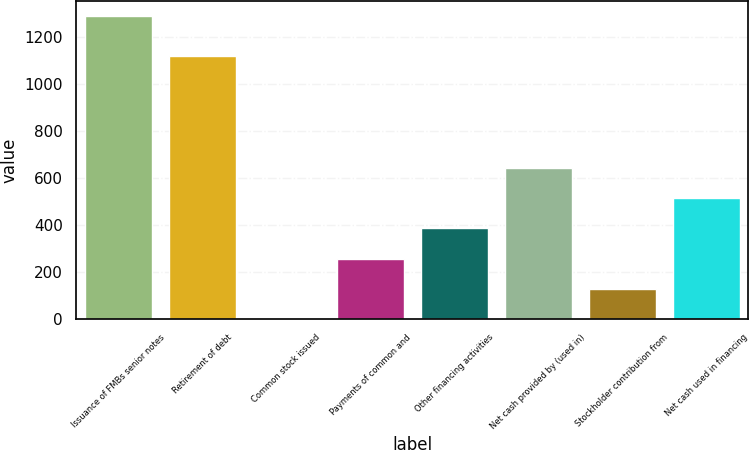Convert chart. <chart><loc_0><loc_0><loc_500><loc_500><bar_chart><fcel>Issuance of FMBs senior notes<fcel>Retirement of debt<fcel>Common stock issued<fcel>Payments of common and<fcel>Other financing activities<fcel>Net cash provided by (used in)<fcel>Stockholder contribution from<fcel>Net cash used in financing<nl><fcel>1292<fcel>1121<fcel>1<fcel>259.2<fcel>388.3<fcel>646.5<fcel>130.1<fcel>517.4<nl></chart> 